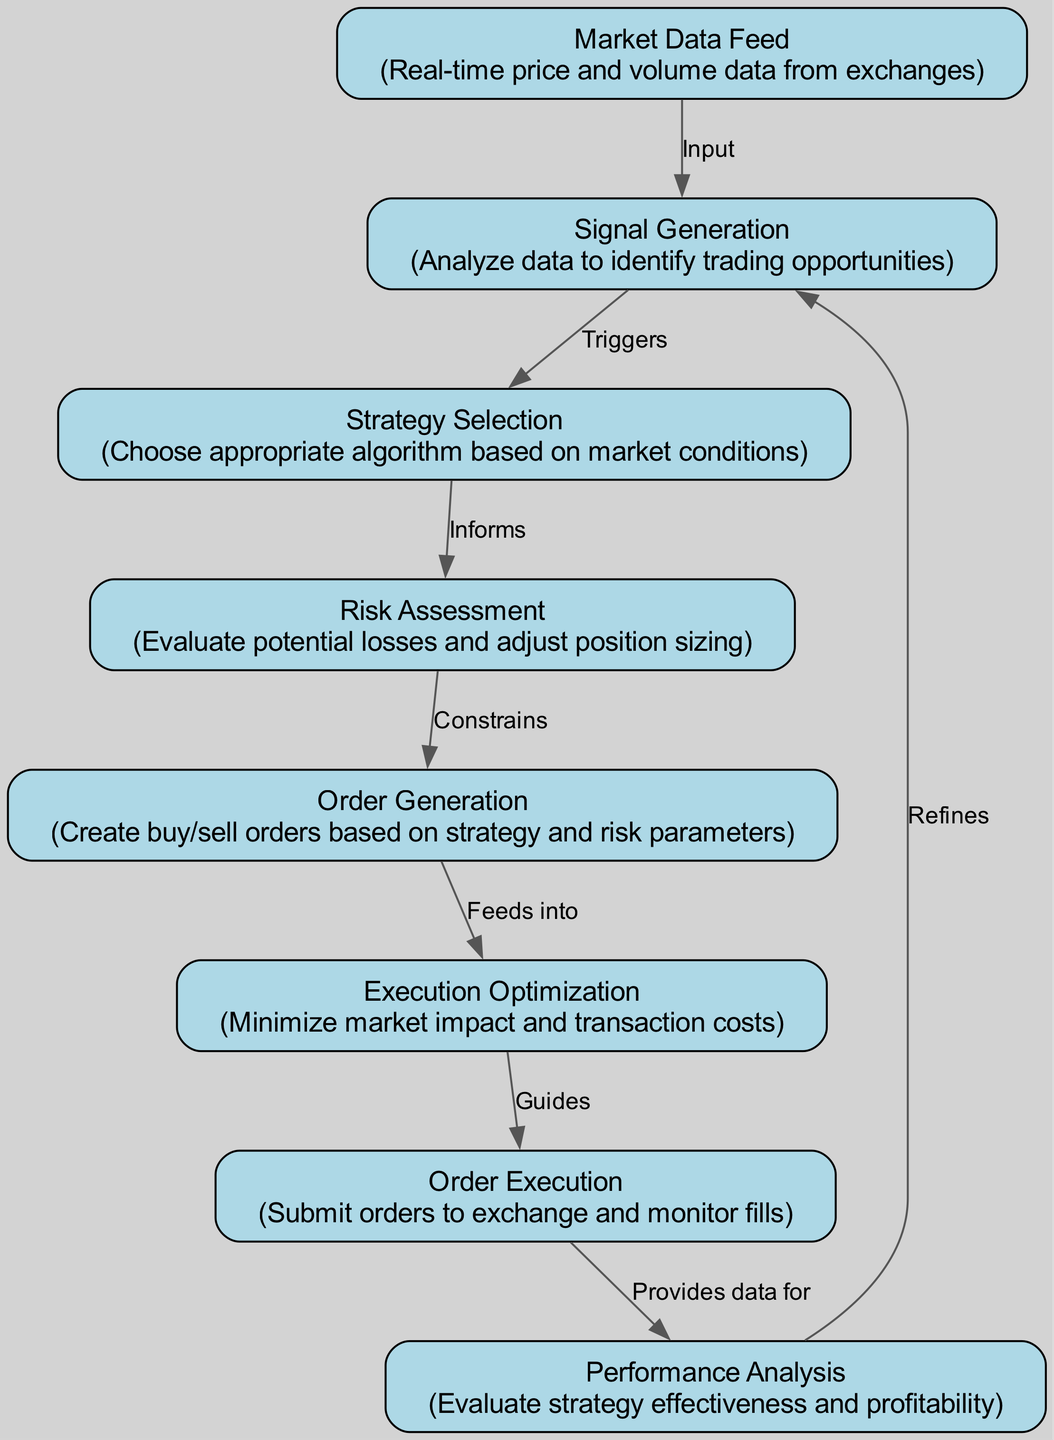What is the first node in the process flow? The first node is indicated as "Market Data Feed," which is responsible for receiving real-time price and volume data from exchanges.
Answer: Market Data Feed How many nodes are there in the diagram? By counting each unique node listed in the data, we find there are a total of eight nodes in the diagram.
Answer: 8 What does the "Signal Generation" node analyze? The "Signal Generation" node analyzes market data, specifically focusing on identifying trading opportunities.
Answer: Trading opportunities Which node feeds into the "Order Generation" node? The "Risk Assessment" node provides constraints for the "Order Generation" node, linking the two in process flow.
Answer: Risk Assessment How many edges connect to the "Execution Optimization" node? Tracing the edges, the "Execution Optimization" node has one edge leading to it from the "Order Generation" node, indicating that it feeds into the execution process.
Answer: 1 Which node provides data for performance analysis? The "Order Execution" node submits orders to the exchange and monitors fills, thus providing essential data for the "Performance Analysis" node.
Answer: Order Execution What relationship does the "Market Data Feed" node have with the "Signal Generation" node? The "Market Data Feed" node serves as the input for the "Signal Generation" node, which utilizes the data to generate signals for trading decisions.
Answer: Input What constrains the "Order Generation" node? The "Risk Assessment" node evaluates potential losses, influencing the order generation process by constraining how orders are created based on risk parameters.
Answer: Risk Assessment What does the "Performance Analysis" node refine? The "Performance Analysis" node refines the "Signal Generation" process by evaluating its effectiveness and profitability, leading to adjustments in strategy.
Answer: Signal Generation 